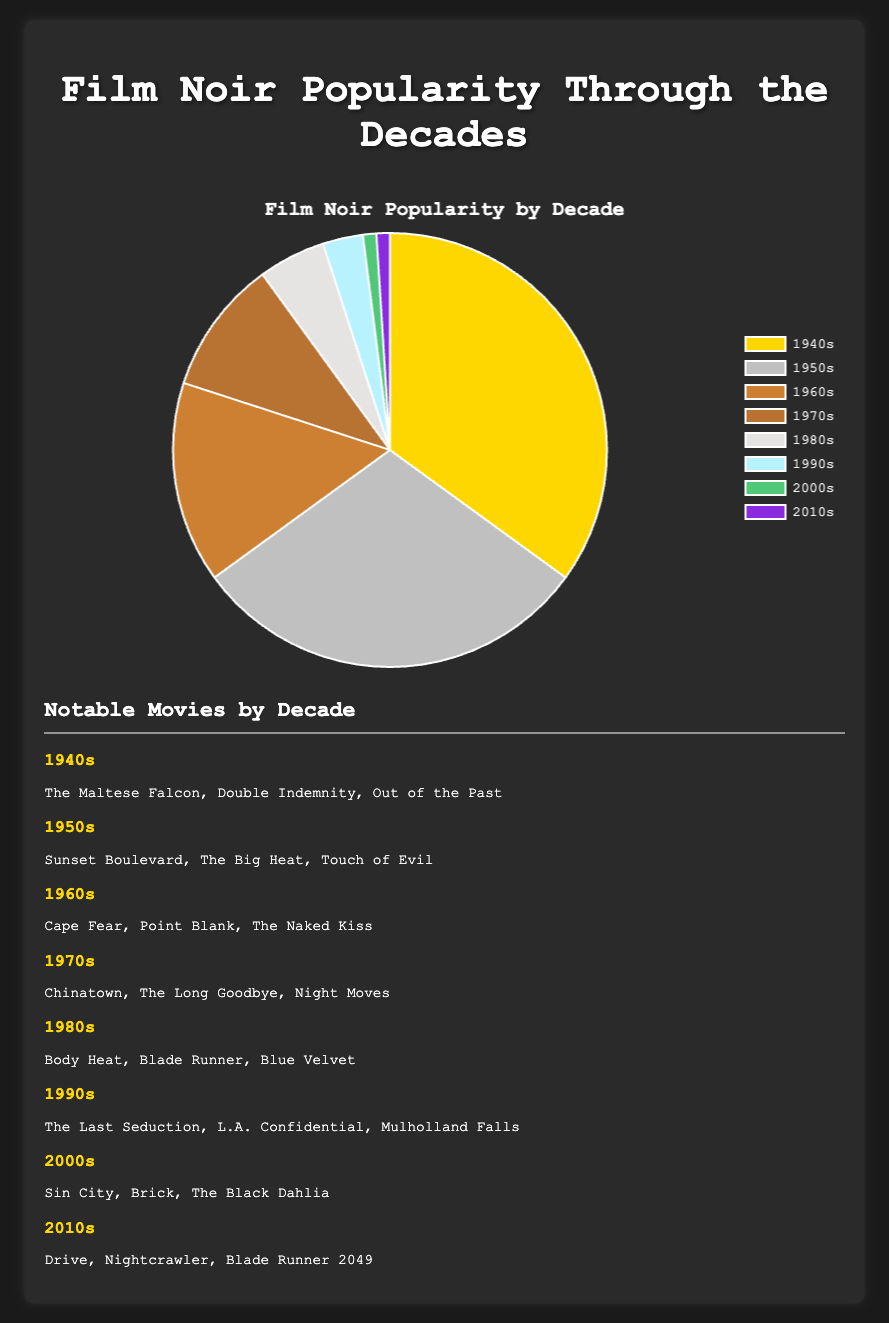What's the most popular decade for Film Noir movies? Looking at the pie chart, identify the segment with the largest percentage. According to the data, the 1940s had the highest percentage at 35%.
Answer: 1940s Which decade has the second highest percentage of Film Noir movies? Examine the pie chart for the segment with the second largest percentage. The data shows that the 1950s had the second highest percentage at 30%.
Answer: 1950s Compare the combined popularity of the 1940s and 1950s with the rest of the decades combined. Which is greater? Sum the percentages for the 1940s and 1950s: 35% + 30% = 65%. Sum the percentages of all other decades: 15% + 10% + 5% + 3% + 1% + 1% = 35%. The 1940s and 1950s combined are more popular.
Answer: 1940s and 1950s Which decade shows the least popularity for Film Noir movies? Identify the pie chart segment with the smallest percentage. Both the 2000s and 2010s have the smallest percentage at 1%.
Answer: 2000s and 2010s How much more popular was the 1970s compared to the 1980s? Subtract the percentage of the 1980s from the 1970s: 10% - 5% = 5%.
Answer: 5% Calculate the total percentage of Film Noir movies from the 1980s onwards. Add the percentages from the 1980s to the 2010s: 5% + 3% + 1% + 1% = 10%.
Answer: 10% Visually, which decade’s segment is colored dark gold? The pie chart uses a specific color for each decade. The dark gold segment represents the 1940s.
Answer: 1940s How many more notable movies are listed from the 1940s compared to the 2000s? The 1940s has 3 notable movies listed, whereas the 2000s has 3 notable movies listed, so the difference is 0.
Answer: 0 